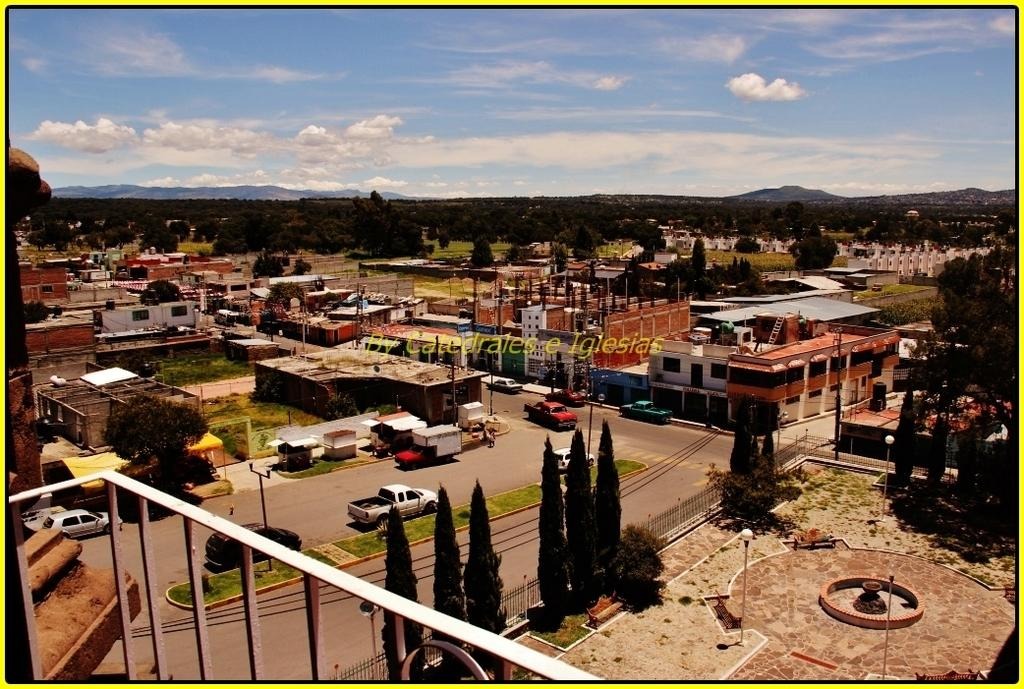What type of location is shown in the image? The image depicts a city. What can be seen on the streets in the image? There are vehicles on the road in the image. What structures are present in the city? There are buildings in the image. What type of natural elements can be seen in the city? There are trees in the image. What is visible above the city in the image? The sky is visible in the image. Where is the zoo located in the image? There is no zoo present in the image; it depicts a city with vehicles, buildings, trees, and the sky. 